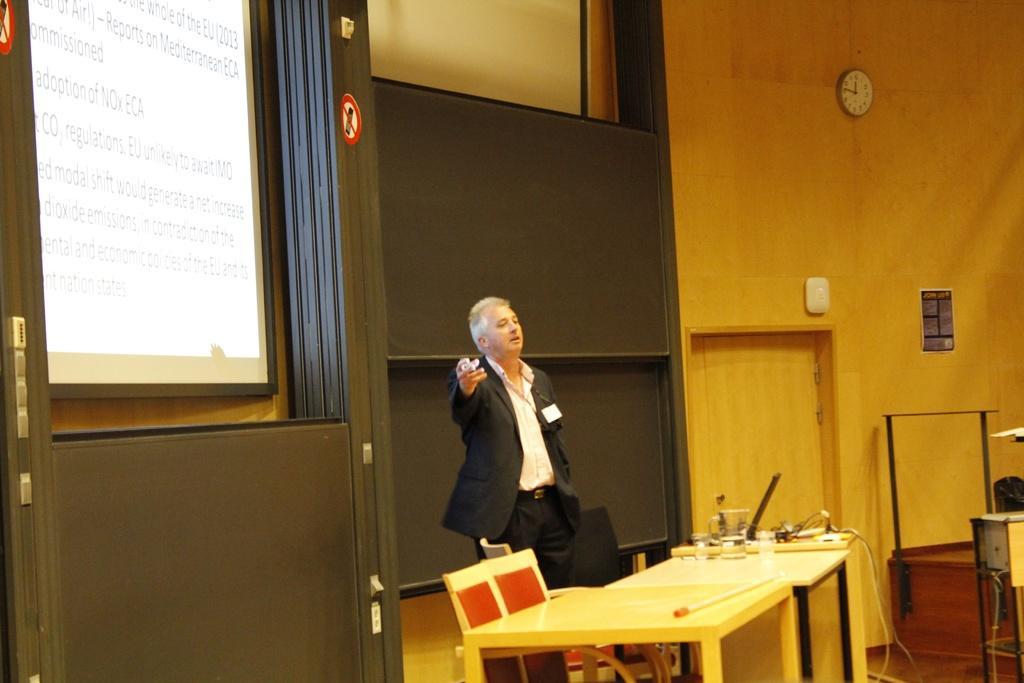Could you give a brief overview of what you see in this image? Man standing,on the table we have glass and here we have chair,screen and on the wall we have clock,poster and here there is door. 